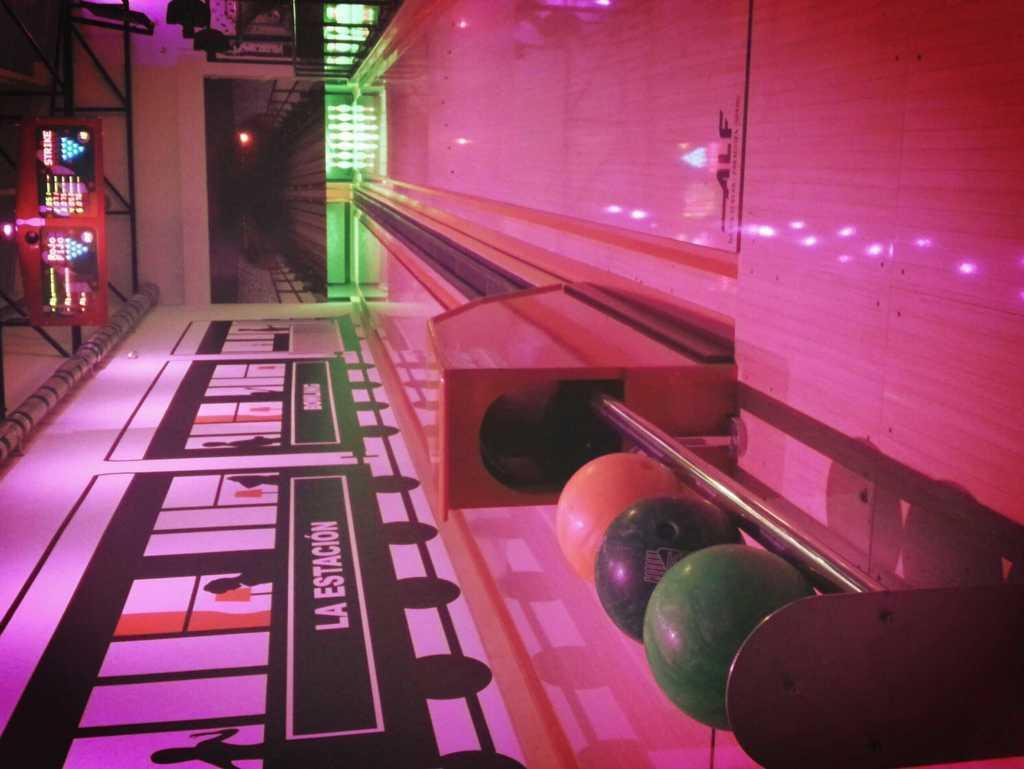In one or two sentences, can you explain what this image depicts? In this picture we can observe a bowling floor. There are white collar pins placed in the background. We can observe LED screen hire. There are three different boards which are in green, black and orange colors. We can observe a wall on the left side. 